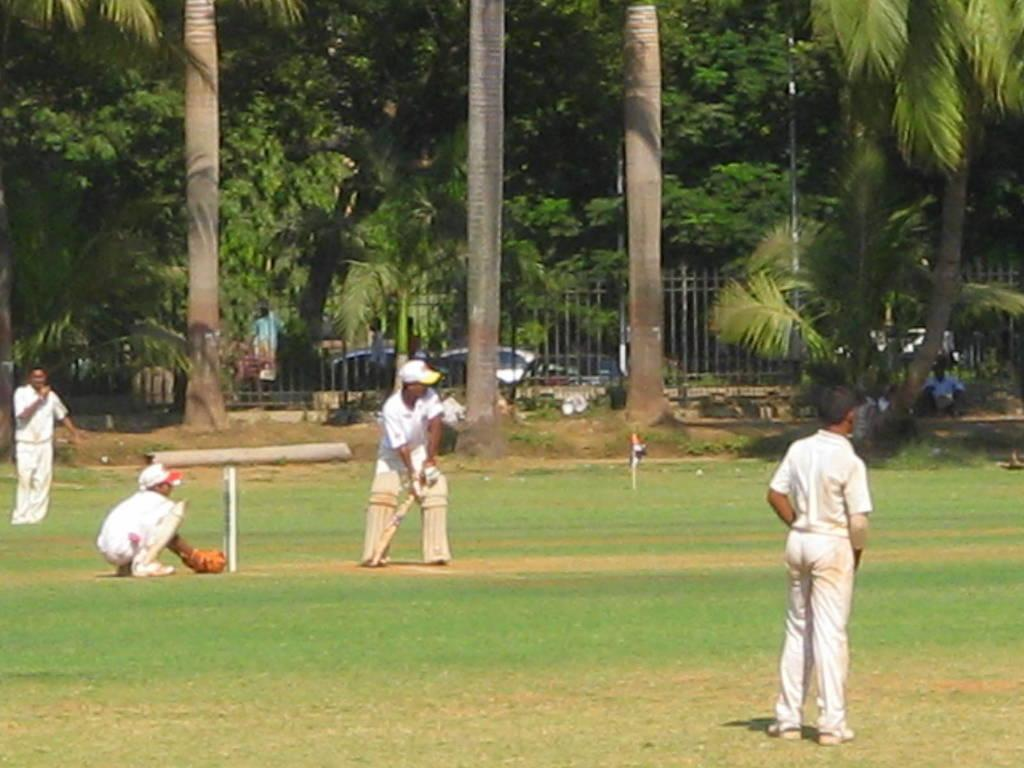What is the man in the middle of the image doing? The man is standing in the middle of the image and holding a bat. What is the man wearing in the image? The man is wearing a white dress in the image. Who else is present in the image? There is another person standing in the right side of the image. What can be seen in the background of the image? Trees are visible in the background of the image. Where are the dolls placed in the image? There are no dolls present in the image. What type of sticks can be seen in the hands of the man in the image? The man is holding a bat, not sticks, in the image. 